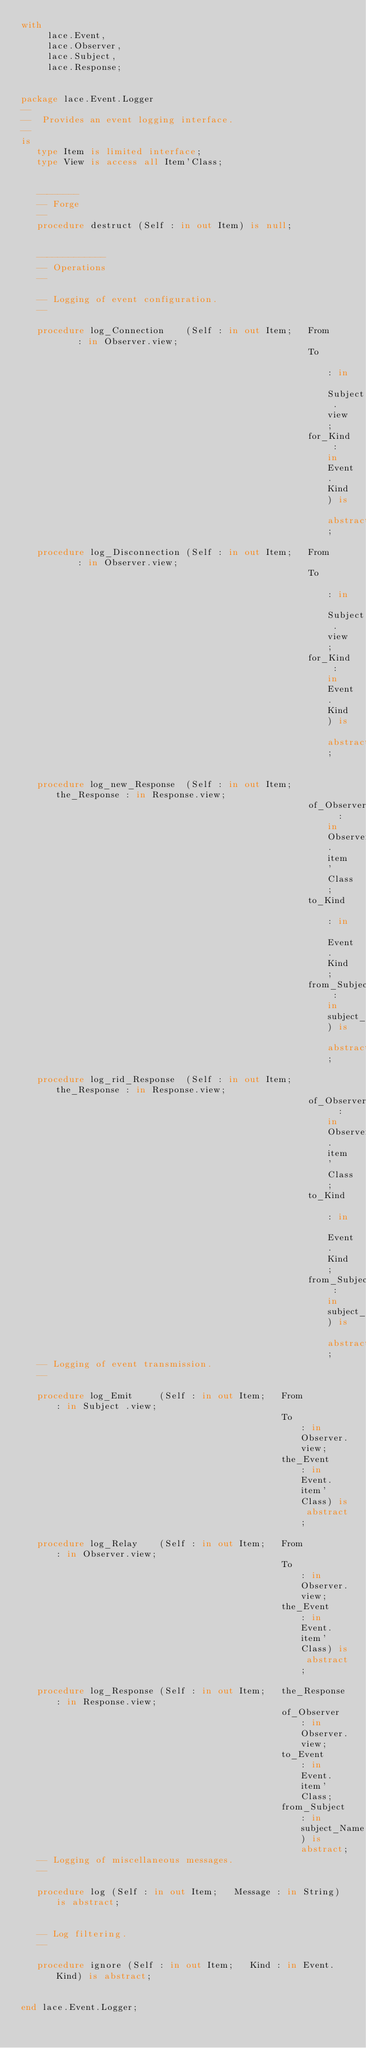Convert code to text. <code><loc_0><loc_0><loc_500><loc_500><_Ada_>with
     lace.Event,
     lace.Observer,
     lace.Subject,
     lace.Response;


package lace.Event.Logger
--
--  Provides an event logging interface.
--
is
   type Item is limited interface;
   type View is access all Item'Class;


   --------
   -- Forge
   --
   procedure destruct (Self : in out Item) is null;


   -------------
   -- Operations
   --

   -- Logging of event configuration.
   --

   procedure log_Connection    (Self : in out Item;   From     : in Observer.view;
                                                      To       : in Subject .view;
                                                      for_Kind : in Event.Kind) is abstract;

   procedure log_Disconnection (Self : in out Item;   From     : in Observer.view;
                                                      To       : in Subject .view;
                                                      for_Kind : in Event.Kind) is abstract;


   procedure log_new_Response  (Self : in out Item;   the_Response : in Response.view;
                                                      of_Observer  : in Observer.item'Class;
                                                      to_Kind      : in Event.Kind;
                                                      from_Subject : in subject_Name) is abstract;

   procedure log_rid_Response  (Self : in out Item;   the_Response : in Response.view;
                                                      of_Observer  : in Observer.item'Class;
                                                      to_Kind      : in Event.Kind;
                                                      from_Subject : in subject_Name) is abstract;
   -- Logging of event transmission.
   --

   procedure log_Emit     (Self : in out Item;   From         : in Subject .view;
                                                 To           : in Observer.view;
                                                 the_Event    : in Event.item'Class) is abstract;

   procedure log_Relay    (Self : in out Item;   From         : in Observer.view;
                                                 To           : in Observer.view;
                                                 the_Event    : in Event.item'Class) is abstract;

   procedure log_Response (Self : in out Item;   the_Response : in Response.view;
                                                 of_Observer  : in Observer.view;
                                                 to_Event     : in Event.item'Class;
                                                 from_Subject : in subject_Name) is abstract;
   -- Logging of miscellaneous messages.
   --

   procedure log (Self : in out Item;   Message : in String) is abstract;


   -- Log filtering.
   --

   procedure ignore (Self : in out Item;   Kind : in Event.Kind) is abstract;


end lace.Event.Logger;
</code> 